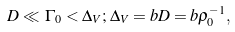Convert formula to latex. <formula><loc_0><loc_0><loc_500><loc_500>D \ll \, \Gamma _ { 0 } < \Delta _ { V } ; \, \Delta _ { V } = b D = b \rho _ { 0 } ^ { - 1 } ,</formula> 